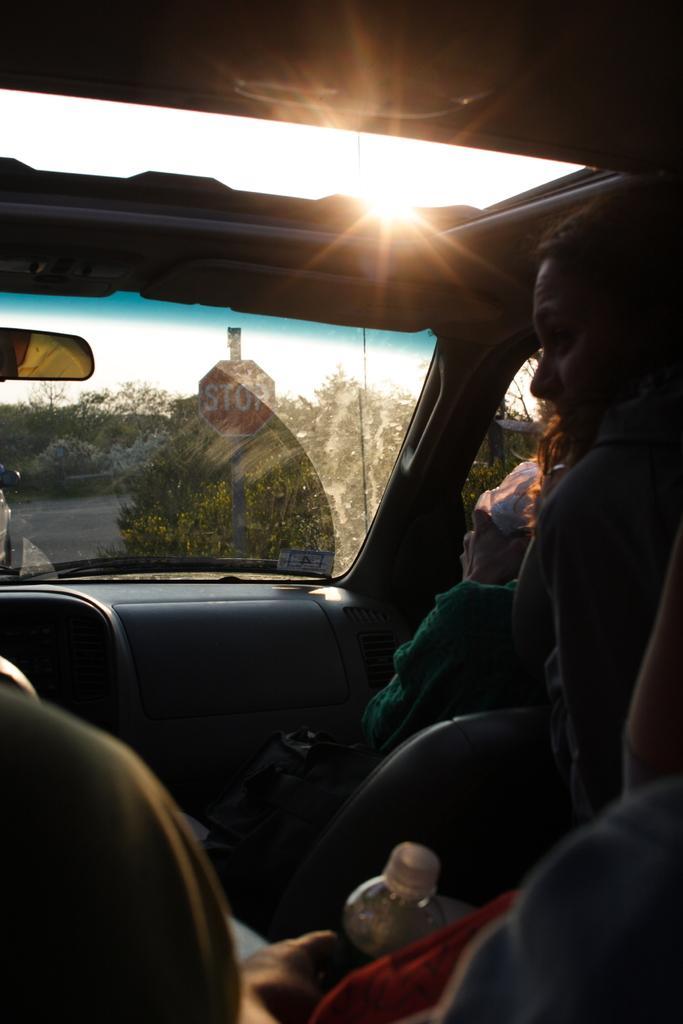In one or two sentences, can you explain what this image depicts? This image is taken inside a car, where we can see people sitting and one among them is holding a water bottle, through the glass we can see a stop board and plants. 